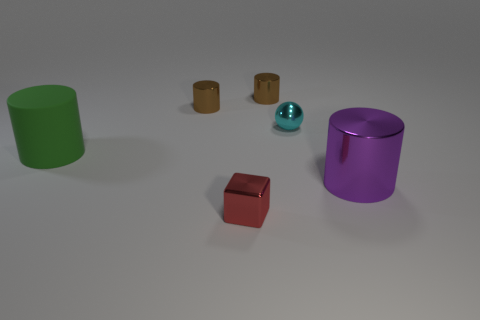What materials do these objects seem to be made of? The large green object appears to be made of rubber due to its matte surface, the red and purple objects have a metallic sheen suggesting they could be made of metal, whereas the small brown cylinders look like they could be wooden due to their grainy texture and color. 